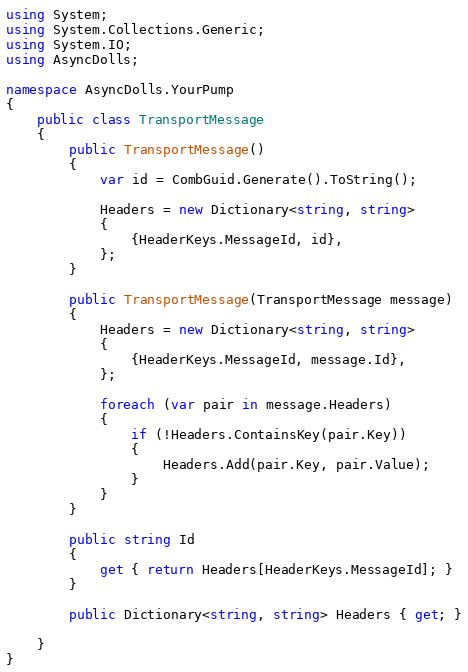<code> <loc_0><loc_0><loc_500><loc_500><_C#_>using System;
using System.Collections.Generic;
using System.IO;
using AsyncDolls;

namespace AsyncDolls.YourPump
{
    public class TransportMessage
    {
        public TransportMessage()
        {
            var id = CombGuid.Generate().ToString();

            Headers = new Dictionary<string, string>
            {
                {HeaderKeys.MessageId, id},
            };
        }

        public TransportMessage(TransportMessage message)
        {
            Headers = new Dictionary<string, string>
            {
                {HeaderKeys.MessageId, message.Id},
            };

            foreach (var pair in message.Headers)
            {
                if (!Headers.ContainsKey(pair.Key))
                {
                    Headers.Add(pair.Key, pair.Value);
                }
            }
        }

        public string Id
        {
            get { return Headers[HeaderKeys.MessageId]; }
        }

        public Dictionary<string, string> Headers { get; }

    }
}</code> 